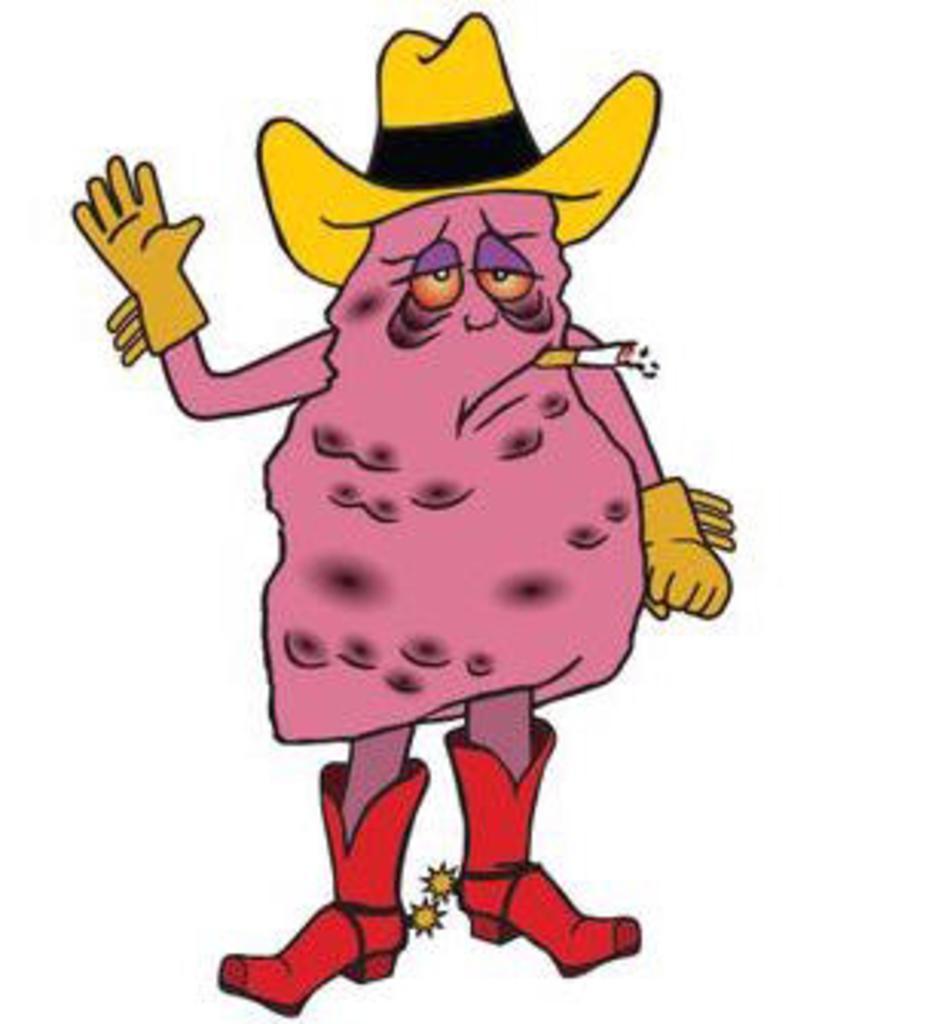Could you give a brief overview of what you see in this image? In this picture we observe a cartoon character who is wearing a red boots, yellow hat and gloves is smoking a cigar. 